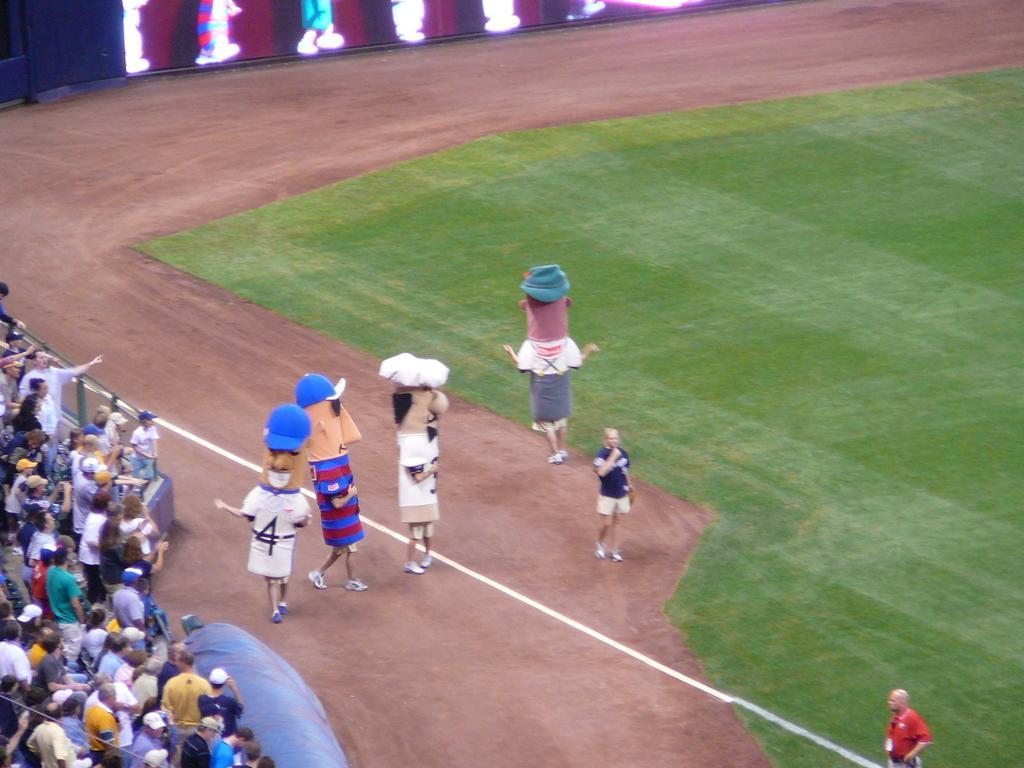Can you describe this image briefly? In the picture we can see a playground and on it we can see some people are standing and they are in different costumes and behind them we can see the people are standing and watching them. 